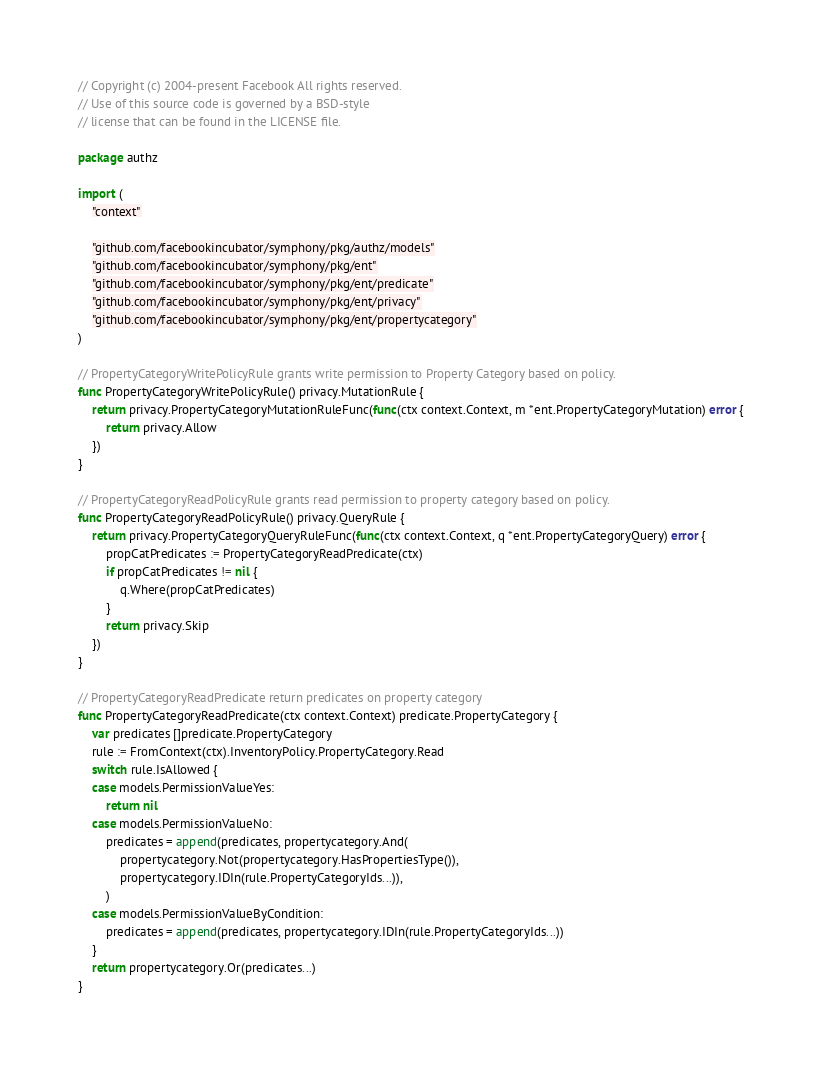Convert code to text. <code><loc_0><loc_0><loc_500><loc_500><_Go_>// Copyright (c) 2004-present Facebook All rights reserved.
// Use of this source code is governed by a BSD-style
// license that can be found in the LICENSE file.

package authz

import (
	"context"

	"github.com/facebookincubator/symphony/pkg/authz/models"
	"github.com/facebookincubator/symphony/pkg/ent"
	"github.com/facebookincubator/symphony/pkg/ent/predicate"
	"github.com/facebookincubator/symphony/pkg/ent/privacy"
	"github.com/facebookincubator/symphony/pkg/ent/propertycategory"
)

// PropertyCategoryWritePolicyRule grants write permission to Property Category based on policy.
func PropertyCategoryWritePolicyRule() privacy.MutationRule {
	return privacy.PropertyCategoryMutationRuleFunc(func(ctx context.Context, m *ent.PropertyCategoryMutation) error {
		return privacy.Allow
	})
}

// PropertyCategoryReadPolicyRule grants read permission to property category based on policy.
func PropertyCategoryReadPolicyRule() privacy.QueryRule {
	return privacy.PropertyCategoryQueryRuleFunc(func(ctx context.Context, q *ent.PropertyCategoryQuery) error {
		propCatPredicates := PropertyCategoryReadPredicate(ctx)
		if propCatPredicates != nil {
			q.Where(propCatPredicates)
		}
		return privacy.Skip
	})
}

// PropertyCategoryReadPredicate return predicates on property category
func PropertyCategoryReadPredicate(ctx context.Context) predicate.PropertyCategory {
	var predicates []predicate.PropertyCategory
	rule := FromContext(ctx).InventoryPolicy.PropertyCategory.Read
	switch rule.IsAllowed {
	case models.PermissionValueYes:
		return nil
	case models.PermissionValueNo:
		predicates = append(predicates, propertycategory.And(
			propertycategory.Not(propertycategory.HasPropertiesType()),
			propertycategory.IDIn(rule.PropertyCategoryIds...)),
		)
	case models.PermissionValueByCondition:
		predicates = append(predicates, propertycategory.IDIn(rule.PropertyCategoryIds...))
	}
	return propertycategory.Or(predicates...)
}
</code> 